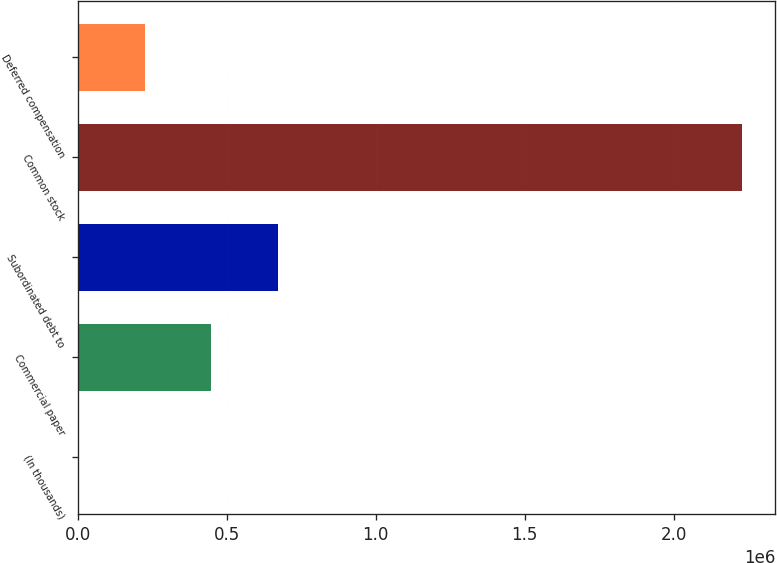Convert chart to OTSL. <chart><loc_0><loc_0><loc_500><loc_500><bar_chart><fcel>(In thousands)<fcel>Commercial paper<fcel>Subordinated debt to<fcel>Common stock<fcel>Deferred compensation<nl><fcel>2006<fcel>447665<fcel>670495<fcel>2.2303e+06<fcel>224836<nl></chart> 